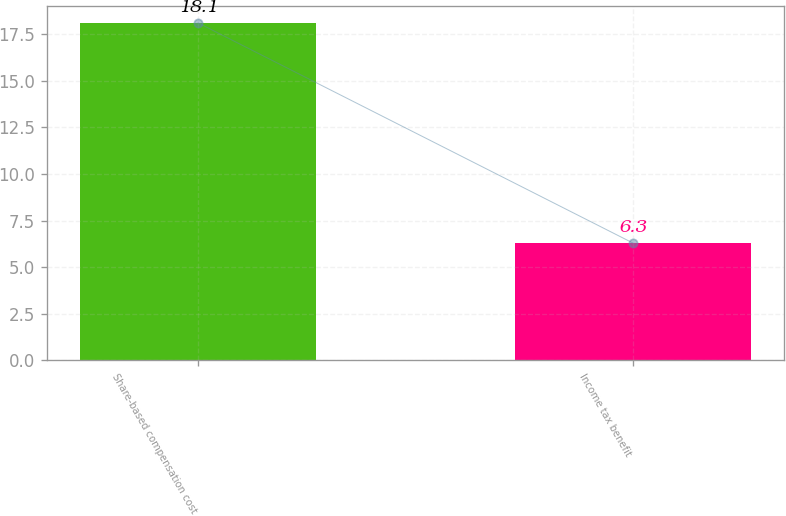<chart> <loc_0><loc_0><loc_500><loc_500><bar_chart><fcel>Share-based compensation cost<fcel>Income tax benefit<nl><fcel>18.1<fcel>6.3<nl></chart> 